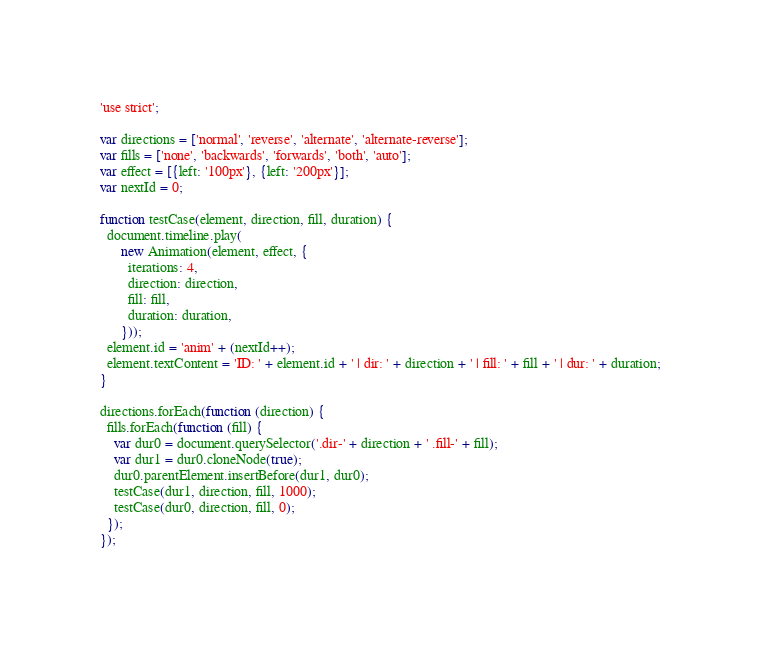<code> <loc_0><loc_0><loc_500><loc_500><_JavaScript_>
'use strict';

var directions = ['normal', 'reverse', 'alternate', 'alternate-reverse'];
var fills = ['none', 'backwards', 'forwards', 'both', 'auto'];
var effect = [{left: '100px'}, {left: '200px'}];
var nextId = 0;

function testCase(element, direction, fill, duration) {
  document.timeline.play(
      new Animation(element, effect, {
        iterations: 4,
        direction: direction,
        fill: fill,
        duration: duration,
      }));
  element.id = 'anim' + (nextId++);
  element.textContent = 'ID: ' + element.id + ' | dir: ' + direction + ' | fill: ' + fill + ' | dur: ' + duration;
}

directions.forEach(function (direction) {
  fills.forEach(function (fill) {
    var dur0 = document.querySelector('.dir-' + direction + ' .fill-' + fill);
    var dur1 = dur0.cloneNode(true);
    dur0.parentElement.insertBefore(dur1, dur0);
    testCase(dur1, direction, fill, 1000);
    testCase(dur0, direction, fill, 0);
  });
});
</code> 